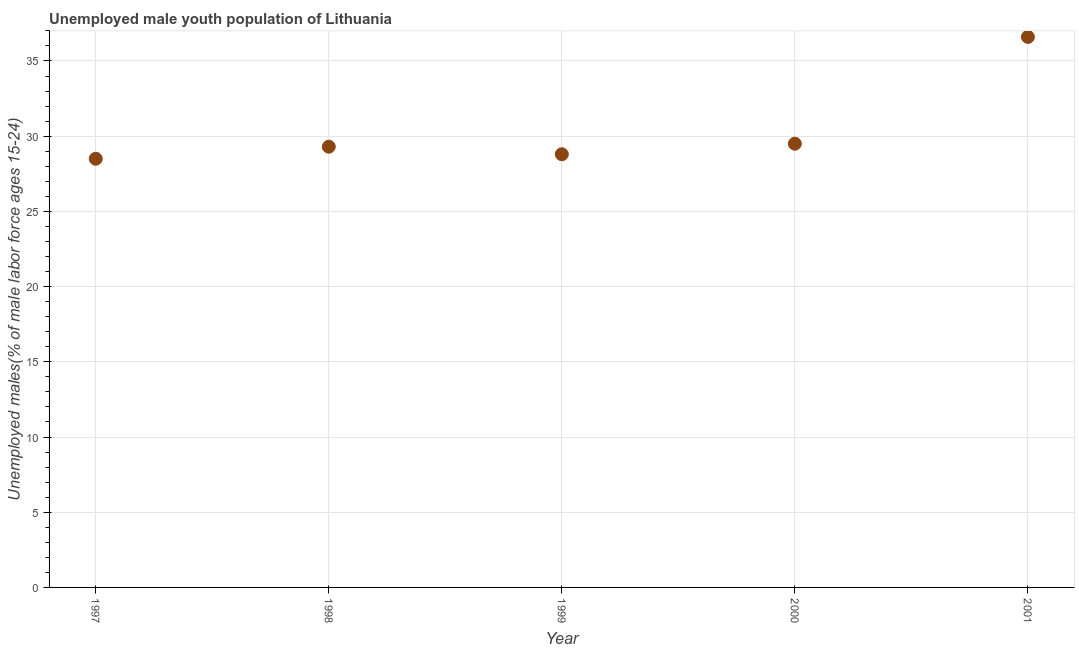What is the unemployed male youth in 2000?
Offer a terse response. 29.5. Across all years, what is the maximum unemployed male youth?
Your response must be concise. 36.6. Across all years, what is the minimum unemployed male youth?
Give a very brief answer. 28.5. In which year was the unemployed male youth maximum?
Keep it short and to the point. 2001. What is the sum of the unemployed male youth?
Make the answer very short. 152.7. What is the average unemployed male youth per year?
Your answer should be very brief. 30.54. What is the median unemployed male youth?
Ensure brevity in your answer.  29.3. In how many years, is the unemployed male youth greater than 12 %?
Offer a very short reply. 5. Do a majority of the years between 2000 and 1998 (inclusive) have unemployed male youth greater than 32 %?
Offer a very short reply. No. What is the ratio of the unemployed male youth in 2000 to that in 2001?
Give a very brief answer. 0.81. Is the difference between the unemployed male youth in 1999 and 2001 greater than the difference between any two years?
Give a very brief answer. No. What is the difference between the highest and the second highest unemployed male youth?
Make the answer very short. 7.1. Is the sum of the unemployed male youth in 1997 and 1999 greater than the maximum unemployed male youth across all years?
Your answer should be very brief. Yes. What is the difference between the highest and the lowest unemployed male youth?
Keep it short and to the point. 8.1. In how many years, is the unemployed male youth greater than the average unemployed male youth taken over all years?
Your answer should be compact. 1. Does the unemployed male youth monotonically increase over the years?
Provide a short and direct response. No. How many years are there in the graph?
Offer a terse response. 5. Are the values on the major ticks of Y-axis written in scientific E-notation?
Offer a very short reply. No. Does the graph contain any zero values?
Make the answer very short. No. Does the graph contain grids?
Make the answer very short. Yes. What is the title of the graph?
Make the answer very short. Unemployed male youth population of Lithuania. What is the label or title of the Y-axis?
Your answer should be very brief. Unemployed males(% of male labor force ages 15-24). What is the Unemployed males(% of male labor force ages 15-24) in 1997?
Your answer should be very brief. 28.5. What is the Unemployed males(% of male labor force ages 15-24) in 1998?
Your answer should be very brief. 29.3. What is the Unemployed males(% of male labor force ages 15-24) in 1999?
Your response must be concise. 28.8. What is the Unemployed males(% of male labor force ages 15-24) in 2000?
Your answer should be very brief. 29.5. What is the Unemployed males(% of male labor force ages 15-24) in 2001?
Make the answer very short. 36.6. What is the difference between the Unemployed males(% of male labor force ages 15-24) in 1998 and 2001?
Make the answer very short. -7.3. What is the difference between the Unemployed males(% of male labor force ages 15-24) in 1999 and 2000?
Keep it short and to the point. -0.7. What is the difference between the Unemployed males(% of male labor force ages 15-24) in 1999 and 2001?
Provide a short and direct response. -7.8. What is the ratio of the Unemployed males(% of male labor force ages 15-24) in 1997 to that in 1998?
Provide a succinct answer. 0.97. What is the ratio of the Unemployed males(% of male labor force ages 15-24) in 1997 to that in 2000?
Provide a succinct answer. 0.97. What is the ratio of the Unemployed males(% of male labor force ages 15-24) in 1997 to that in 2001?
Offer a terse response. 0.78. What is the ratio of the Unemployed males(% of male labor force ages 15-24) in 1998 to that in 2001?
Give a very brief answer. 0.8. What is the ratio of the Unemployed males(% of male labor force ages 15-24) in 1999 to that in 2001?
Your answer should be very brief. 0.79. What is the ratio of the Unemployed males(% of male labor force ages 15-24) in 2000 to that in 2001?
Your answer should be very brief. 0.81. 